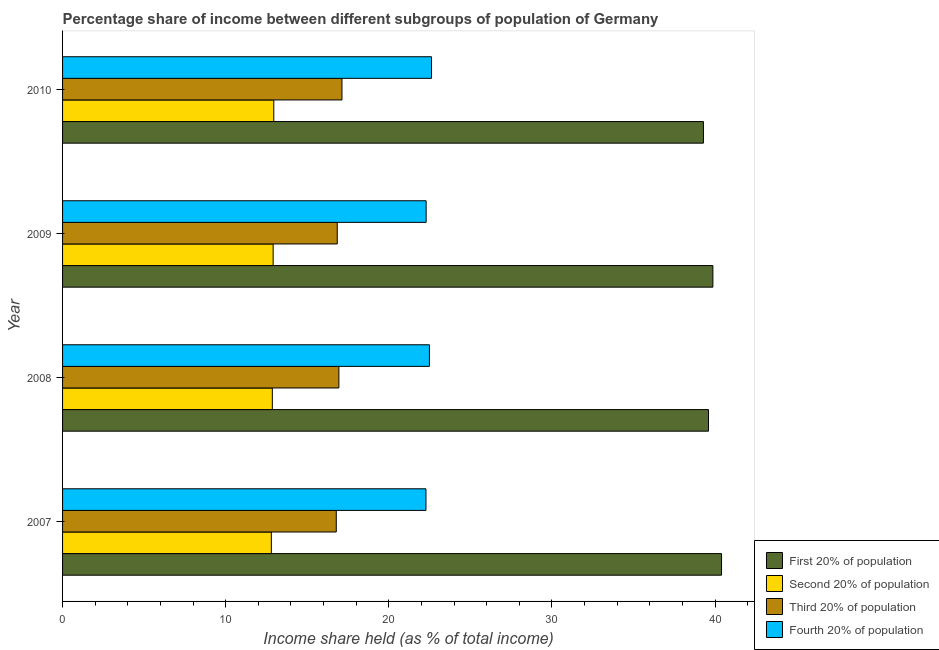Are the number of bars per tick equal to the number of legend labels?
Provide a short and direct response. Yes. How many bars are there on the 4th tick from the top?
Provide a succinct answer. 4. How many bars are there on the 1st tick from the bottom?
Provide a short and direct response. 4. What is the label of the 1st group of bars from the top?
Offer a terse response. 2010. In how many cases, is the number of bars for a given year not equal to the number of legend labels?
Provide a short and direct response. 0. What is the share of the income held by third 20% of the population in 2010?
Give a very brief answer. 17.13. Across all years, what is the maximum share of the income held by second 20% of the population?
Offer a terse response. 12.95. Across all years, what is the minimum share of the income held by third 20% of the population?
Keep it short and to the point. 16.78. In which year was the share of the income held by second 20% of the population maximum?
Offer a terse response. 2010. What is the total share of the income held by second 20% of the population in the graph?
Provide a short and direct response. 51.52. What is the difference between the share of the income held by fourth 20% of the population in 2010 and the share of the income held by first 20% of the population in 2009?
Make the answer very short. -17.25. What is the average share of the income held by first 20% of the population per year?
Provide a succinct answer. 39.79. In the year 2010, what is the difference between the share of the income held by second 20% of the population and share of the income held by first 20% of the population?
Your response must be concise. -26.34. In how many years, is the share of the income held by first 20% of the population greater than 26 %?
Make the answer very short. 4. Is the share of the income held by third 20% of the population in 2007 less than that in 2008?
Offer a very short reply. Yes. Is the difference between the share of the income held by first 20% of the population in 2007 and 2010 greater than the difference between the share of the income held by fourth 20% of the population in 2007 and 2010?
Ensure brevity in your answer.  Yes. What is the difference between the highest and the second highest share of the income held by third 20% of the population?
Your answer should be very brief. 0.19. What is the difference between the highest and the lowest share of the income held by third 20% of the population?
Your response must be concise. 0.35. In how many years, is the share of the income held by second 20% of the population greater than the average share of the income held by second 20% of the population taken over all years?
Make the answer very short. 2. Is the sum of the share of the income held by fourth 20% of the population in 2008 and 2009 greater than the maximum share of the income held by third 20% of the population across all years?
Give a very brief answer. Yes. Is it the case that in every year, the sum of the share of the income held by second 20% of the population and share of the income held by fourth 20% of the population is greater than the sum of share of the income held by third 20% of the population and share of the income held by first 20% of the population?
Keep it short and to the point. No. What does the 4th bar from the top in 2010 represents?
Provide a short and direct response. First 20% of population. What does the 3rd bar from the bottom in 2009 represents?
Provide a succinct answer. Third 20% of population. How many years are there in the graph?
Provide a succinct answer. 4. What is the difference between two consecutive major ticks on the X-axis?
Your answer should be compact. 10. Does the graph contain grids?
Provide a succinct answer. No. Where does the legend appear in the graph?
Provide a succinct answer. Bottom right. How are the legend labels stacked?
Provide a short and direct response. Vertical. What is the title of the graph?
Your response must be concise. Percentage share of income between different subgroups of population of Germany. Does "Management rating" appear as one of the legend labels in the graph?
Make the answer very short. No. What is the label or title of the X-axis?
Ensure brevity in your answer.  Income share held (as % of total income). What is the label or title of the Y-axis?
Offer a terse response. Year. What is the Income share held (as % of total income) of First 20% of population in 2007?
Offer a very short reply. 40.4. What is the Income share held (as % of total income) in Third 20% of population in 2007?
Keep it short and to the point. 16.78. What is the Income share held (as % of total income) of Fourth 20% of population in 2007?
Ensure brevity in your answer.  22.28. What is the Income share held (as % of total income) in First 20% of population in 2008?
Offer a very short reply. 39.6. What is the Income share held (as % of total income) of Second 20% of population in 2008?
Your answer should be very brief. 12.86. What is the Income share held (as % of total income) of Third 20% of population in 2008?
Your response must be concise. 16.94. What is the Income share held (as % of total income) in Fourth 20% of population in 2008?
Your answer should be compact. 22.49. What is the Income share held (as % of total income) of First 20% of population in 2009?
Keep it short and to the point. 39.87. What is the Income share held (as % of total income) of Second 20% of population in 2009?
Provide a succinct answer. 12.91. What is the Income share held (as % of total income) in Third 20% of population in 2009?
Your answer should be compact. 16.84. What is the Income share held (as % of total income) in Fourth 20% of population in 2009?
Your answer should be very brief. 22.29. What is the Income share held (as % of total income) in First 20% of population in 2010?
Offer a terse response. 39.29. What is the Income share held (as % of total income) of Second 20% of population in 2010?
Give a very brief answer. 12.95. What is the Income share held (as % of total income) in Third 20% of population in 2010?
Keep it short and to the point. 17.13. What is the Income share held (as % of total income) of Fourth 20% of population in 2010?
Give a very brief answer. 22.62. Across all years, what is the maximum Income share held (as % of total income) of First 20% of population?
Offer a very short reply. 40.4. Across all years, what is the maximum Income share held (as % of total income) of Second 20% of population?
Your answer should be compact. 12.95. Across all years, what is the maximum Income share held (as % of total income) in Third 20% of population?
Keep it short and to the point. 17.13. Across all years, what is the maximum Income share held (as % of total income) in Fourth 20% of population?
Your response must be concise. 22.62. Across all years, what is the minimum Income share held (as % of total income) in First 20% of population?
Offer a very short reply. 39.29. Across all years, what is the minimum Income share held (as % of total income) in Third 20% of population?
Your response must be concise. 16.78. Across all years, what is the minimum Income share held (as % of total income) in Fourth 20% of population?
Make the answer very short. 22.28. What is the total Income share held (as % of total income) of First 20% of population in the graph?
Keep it short and to the point. 159.16. What is the total Income share held (as % of total income) of Second 20% of population in the graph?
Your answer should be compact. 51.52. What is the total Income share held (as % of total income) of Third 20% of population in the graph?
Give a very brief answer. 67.69. What is the total Income share held (as % of total income) of Fourth 20% of population in the graph?
Offer a very short reply. 89.68. What is the difference between the Income share held (as % of total income) of First 20% of population in 2007 and that in 2008?
Provide a short and direct response. 0.8. What is the difference between the Income share held (as % of total income) of Second 20% of population in 2007 and that in 2008?
Ensure brevity in your answer.  -0.06. What is the difference between the Income share held (as % of total income) in Third 20% of population in 2007 and that in 2008?
Your response must be concise. -0.16. What is the difference between the Income share held (as % of total income) in Fourth 20% of population in 2007 and that in 2008?
Give a very brief answer. -0.21. What is the difference between the Income share held (as % of total income) in First 20% of population in 2007 and that in 2009?
Ensure brevity in your answer.  0.53. What is the difference between the Income share held (as % of total income) of Second 20% of population in 2007 and that in 2009?
Your answer should be compact. -0.11. What is the difference between the Income share held (as % of total income) in Third 20% of population in 2007 and that in 2009?
Offer a very short reply. -0.06. What is the difference between the Income share held (as % of total income) of Fourth 20% of population in 2007 and that in 2009?
Offer a terse response. -0.01. What is the difference between the Income share held (as % of total income) in First 20% of population in 2007 and that in 2010?
Offer a very short reply. 1.11. What is the difference between the Income share held (as % of total income) in Second 20% of population in 2007 and that in 2010?
Make the answer very short. -0.15. What is the difference between the Income share held (as % of total income) in Third 20% of population in 2007 and that in 2010?
Ensure brevity in your answer.  -0.35. What is the difference between the Income share held (as % of total income) of Fourth 20% of population in 2007 and that in 2010?
Make the answer very short. -0.34. What is the difference between the Income share held (as % of total income) in First 20% of population in 2008 and that in 2009?
Give a very brief answer. -0.27. What is the difference between the Income share held (as % of total income) of First 20% of population in 2008 and that in 2010?
Your answer should be compact. 0.31. What is the difference between the Income share held (as % of total income) in Second 20% of population in 2008 and that in 2010?
Your response must be concise. -0.09. What is the difference between the Income share held (as % of total income) of Third 20% of population in 2008 and that in 2010?
Keep it short and to the point. -0.19. What is the difference between the Income share held (as % of total income) of Fourth 20% of population in 2008 and that in 2010?
Your answer should be compact. -0.13. What is the difference between the Income share held (as % of total income) in First 20% of population in 2009 and that in 2010?
Offer a very short reply. 0.58. What is the difference between the Income share held (as % of total income) in Second 20% of population in 2009 and that in 2010?
Provide a short and direct response. -0.04. What is the difference between the Income share held (as % of total income) in Third 20% of population in 2009 and that in 2010?
Your response must be concise. -0.29. What is the difference between the Income share held (as % of total income) in Fourth 20% of population in 2009 and that in 2010?
Provide a short and direct response. -0.33. What is the difference between the Income share held (as % of total income) of First 20% of population in 2007 and the Income share held (as % of total income) of Second 20% of population in 2008?
Provide a short and direct response. 27.54. What is the difference between the Income share held (as % of total income) of First 20% of population in 2007 and the Income share held (as % of total income) of Third 20% of population in 2008?
Keep it short and to the point. 23.46. What is the difference between the Income share held (as % of total income) in First 20% of population in 2007 and the Income share held (as % of total income) in Fourth 20% of population in 2008?
Offer a terse response. 17.91. What is the difference between the Income share held (as % of total income) of Second 20% of population in 2007 and the Income share held (as % of total income) of Third 20% of population in 2008?
Your answer should be very brief. -4.14. What is the difference between the Income share held (as % of total income) of Second 20% of population in 2007 and the Income share held (as % of total income) of Fourth 20% of population in 2008?
Make the answer very short. -9.69. What is the difference between the Income share held (as % of total income) of Third 20% of population in 2007 and the Income share held (as % of total income) of Fourth 20% of population in 2008?
Give a very brief answer. -5.71. What is the difference between the Income share held (as % of total income) of First 20% of population in 2007 and the Income share held (as % of total income) of Second 20% of population in 2009?
Offer a very short reply. 27.49. What is the difference between the Income share held (as % of total income) of First 20% of population in 2007 and the Income share held (as % of total income) of Third 20% of population in 2009?
Provide a succinct answer. 23.56. What is the difference between the Income share held (as % of total income) of First 20% of population in 2007 and the Income share held (as % of total income) of Fourth 20% of population in 2009?
Offer a very short reply. 18.11. What is the difference between the Income share held (as % of total income) of Second 20% of population in 2007 and the Income share held (as % of total income) of Third 20% of population in 2009?
Make the answer very short. -4.04. What is the difference between the Income share held (as % of total income) of Second 20% of population in 2007 and the Income share held (as % of total income) of Fourth 20% of population in 2009?
Give a very brief answer. -9.49. What is the difference between the Income share held (as % of total income) in Third 20% of population in 2007 and the Income share held (as % of total income) in Fourth 20% of population in 2009?
Keep it short and to the point. -5.51. What is the difference between the Income share held (as % of total income) of First 20% of population in 2007 and the Income share held (as % of total income) of Second 20% of population in 2010?
Offer a very short reply. 27.45. What is the difference between the Income share held (as % of total income) in First 20% of population in 2007 and the Income share held (as % of total income) in Third 20% of population in 2010?
Your response must be concise. 23.27. What is the difference between the Income share held (as % of total income) in First 20% of population in 2007 and the Income share held (as % of total income) in Fourth 20% of population in 2010?
Offer a very short reply. 17.78. What is the difference between the Income share held (as % of total income) of Second 20% of population in 2007 and the Income share held (as % of total income) of Third 20% of population in 2010?
Give a very brief answer. -4.33. What is the difference between the Income share held (as % of total income) in Second 20% of population in 2007 and the Income share held (as % of total income) in Fourth 20% of population in 2010?
Ensure brevity in your answer.  -9.82. What is the difference between the Income share held (as % of total income) in Third 20% of population in 2007 and the Income share held (as % of total income) in Fourth 20% of population in 2010?
Make the answer very short. -5.84. What is the difference between the Income share held (as % of total income) in First 20% of population in 2008 and the Income share held (as % of total income) in Second 20% of population in 2009?
Offer a very short reply. 26.69. What is the difference between the Income share held (as % of total income) in First 20% of population in 2008 and the Income share held (as % of total income) in Third 20% of population in 2009?
Ensure brevity in your answer.  22.76. What is the difference between the Income share held (as % of total income) in First 20% of population in 2008 and the Income share held (as % of total income) in Fourth 20% of population in 2009?
Your answer should be compact. 17.31. What is the difference between the Income share held (as % of total income) in Second 20% of population in 2008 and the Income share held (as % of total income) in Third 20% of population in 2009?
Give a very brief answer. -3.98. What is the difference between the Income share held (as % of total income) in Second 20% of population in 2008 and the Income share held (as % of total income) in Fourth 20% of population in 2009?
Provide a succinct answer. -9.43. What is the difference between the Income share held (as % of total income) of Third 20% of population in 2008 and the Income share held (as % of total income) of Fourth 20% of population in 2009?
Give a very brief answer. -5.35. What is the difference between the Income share held (as % of total income) of First 20% of population in 2008 and the Income share held (as % of total income) of Second 20% of population in 2010?
Your answer should be very brief. 26.65. What is the difference between the Income share held (as % of total income) in First 20% of population in 2008 and the Income share held (as % of total income) in Third 20% of population in 2010?
Provide a succinct answer. 22.47. What is the difference between the Income share held (as % of total income) in First 20% of population in 2008 and the Income share held (as % of total income) in Fourth 20% of population in 2010?
Offer a terse response. 16.98. What is the difference between the Income share held (as % of total income) of Second 20% of population in 2008 and the Income share held (as % of total income) of Third 20% of population in 2010?
Your answer should be very brief. -4.27. What is the difference between the Income share held (as % of total income) of Second 20% of population in 2008 and the Income share held (as % of total income) of Fourth 20% of population in 2010?
Your response must be concise. -9.76. What is the difference between the Income share held (as % of total income) of Third 20% of population in 2008 and the Income share held (as % of total income) of Fourth 20% of population in 2010?
Give a very brief answer. -5.68. What is the difference between the Income share held (as % of total income) in First 20% of population in 2009 and the Income share held (as % of total income) in Second 20% of population in 2010?
Your answer should be very brief. 26.92. What is the difference between the Income share held (as % of total income) of First 20% of population in 2009 and the Income share held (as % of total income) of Third 20% of population in 2010?
Ensure brevity in your answer.  22.74. What is the difference between the Income share held (as % of total income) in First 20% of population in 2009 and the Income share held (as % of total income) in Fourth 20% of population in 2010?
Ensure brevity in your answer.  17.25. What is the difference between the Income share held (as % of total income) in Second 20% of population in 2009 and the Income share held (as % of total income) in Third 20% of population in 2010?
Your answer should be very brief. -4.22. What is the difference between the Income share held (as % of total income) in Second 20% of population in 2009 and the Income share held (as % of total income) in Fourth 20% of population in 2010?
Make the answer very short. -9.71. What is the difference between the Income share held (as % of total income) of Third 20% of population in 2009 and the Income share held (as % of total income) of Fourth 20% of population in 2010?
Give a very brief answer. -5.78. What is the average Income share held (as % of total income) in First 20% of population per year?
Ensure brevity in your answer.  39.79. What is the average Income share held (as % of total income) in Second 20% of population per year?
Keep it short and to the point. 12.88. What is the average Income share held (as % of total income) in Third 20% of population per year?
Your response must be concise. 16.92. What is the average Income share held (as % of total income) of Fourth 20% of population per year?
Make the answer very short. 22.42. In the year 2007, what is the difference between the Income share held (as % of total income) of First 20% of population and Income share held (as % of total income) of Second 20% of population?
Make the answer very short. 27.6. In the year 2007, what is the difference between the Income share held (as % of total income) in First 20% of population and Income share held (as % of total income) in Third 20% of population?
Give a very brief answer. 23.62. In the year 2007, what is the difference between the Income share held (as % of total income) of First 20% of population and Income share held (as % of total income) of Fourth 20% of population?
Keep it short and to the point. 18.12. In the year 2007, what is the difference between the Income share held (as % of total income) in Second 20% of population and Income share held (as % of total income) in Third 20% of population?
Give a very brief answer. -3.98. In the year 2007, what is the difference between the Income share held (as % of total income) in Second 20% of population and Income share held (as % of total income) in Fourth 20% of population?
Keep it short and to the point. -9.48. In the year 2008, what is the difference between the Income share held (as % of total income) in First 20% of population and Income share held (as % of total income) in Second 20% of population?
Your answer should be very brief. 26.74. In the year 2008, what is the difference between the Income share held (as % of total income) of First 20% of population and Income share held (as % of total income) of Third 20% of population?
Give a very brief answer. 22.66. In the year 2008, what is the difference between the Income share held (as % of total income) of First 20% of population and Income share held (as % of total income) of Fourth 20% of population?
Your answer should be compact. 17.11. In the year 2008, what is the difference between the Income share held (as % of total income) in Second 20% of population and Income share held (as % of total income) in Third 20% of population?
Keep it short and to the point. -4.08. In the year 2008, what is the difference between the Income share held (as % of total income) in Second 20% of population and Income share held (as % of total income) in Fourth 20% of population?
Your response must be concise. -9.63. In the year 2008, what is the difference between the Income share held (as % of total income) in Third 20% of population and Income share held (as % of total income) in Fourth 20% of population?
Your answer should be very brief. -5.55. In the year 2009, what is the difference between the Income share held (as % of total income) in First 20% of population and Income share held (as % of total income) in Second 20% of population?
Provide a succinct answer. 26.96. In the year 2009, what is the difference between the Income share held (as % of total income) in First 20% of population and Income share held (as % of total income) in Third 20% of population?
Make the answer very short. 23.03. In the year 2009, what is the difference between the Income share held (as % of total income) in First 20% of population and Income share held (as % of total income) in Fourth 20% of population?
Offer a terse response. 17.58. In the year 2009, what is the difference between the Income share held (as % of total income) of Second 20% of population and Income share held (as % of total income) of Third 20% of population?
Your response must be concise. -3.93. In the year 2009, what is the difference between the Income share held (as % of total income) in Second 20% of population and Income share held (as % of total income) in Fourth 20% of population?
Provide a short and direct response. -9.38. In the year 2009, what is the difference between the Income share held (as % of total income) in Third 20% of population and Income share held (as % of total income) in Fourth 20% of population?
Ensure brevity in your answer.  -5.45. In the year 2010, what is the difference between the Income share held (as % of total income) in First 20% of population and Income share held (as % of total income) in Second 20% of population?
Your answer should be compact. 26.34. In the year 2010, what is the difference between the Income share held (as % of total income) of First 20% of population and Income share held (as % of total income) of Third 20% of population?
Give a very brief answer. 22.16. In the year 2010, what is the difference between the Income share held (as % of total income) in First 20% of population and Income share held (as % of total income) in Fourth 20% of population?
Your answer should be compact. 16.67. In the year 2010, what is the difference between the Income share held (as % of total income) in Second 20% of population and Income share held (as % of total income) in Third 20% of population?
Offer a terse response. -4.18. In the year 2010, what is the difference between the Income share held (as % of total income) of Second 20% of population and Income share held (as % of total income) of Fourth 20% of population?
Your response must be concise. -9.67. In the year 2010, what is the difference between the Income share held (as % of total income) of Third 20% of population and Income share held (as % of total income) of Fourth 20% of population?
Keep it short and to the point. -5.49. What is the ratio of the Income share held (as % of total income) of First 20% of population in 2007 to that in 2008?
Give a very brief answer. 1.02. What is the ratio of the Income share held (as % of total income) of Third 20% of population in 2007 to that in 2008?
Give a very brief answer. 0.99. What is the ratio of the Income share held (as % of total income) in First 20% of population in 2007 to that in 2009?
Make the answer very short. 1.01. What is the ratio of the Income share held (as % of total income) in Third 20% of population in 2007 to that in 2009?
Make the answer very short. 1. What is the ratio of the Income share held (as % of total income) in First 20% of population in 2007 to that in 2010?
Ensure brevity in your answer.  1.03. What is the ratio of the Income share held (as % of total income) in Second 20% of population in 2007 to that in 2010?
Offer a terse response. 0.99. What is the ratio of the Income share held (as % of total income) in Third 20% of population in 2007 to that in 2010?
Provide a short and direct response. 0.98. What is the ratio of the Income share held (as % of total income) of Fourth 20% of population in 2007 to that in 2010?
Give a very brief answer. 0.98. What is the ratio of the Income share held (as % of total income) in First 20% of population in 2008 to that in 2009?
Offer a very short reply. 0.99. What is the ratio of the Income share held (as % of total income) in Second 20% of population in 2008 to that in 2009?
Your answer should be very brief. 1. What is the ratio of the Income share held (as % of total income) of Third 20% of population in 2008 to that in 2009?
Offer a very short reply. 1.01. What is the ratio of the Income share held (as % of total income) in First 20% of population in 2008 to that in 2010?
Your answer should be compact. 1.01. What is the ratio of the Income share held (as % of total income) in Third 20% of population in 2008 to that in 2010?
Ensure brevity in your answer.  0.99. What is the ratio of the Income share held (as % of total income) in First 20% of population in 2009 to that in 2010?
Ensure brevity in your answer.  1.01. What is the ratio of the Income share held (as % of total income) of Second 20% of population in 2009 to that in 2010?
Provide a short and direct response. 1. What is the ratio of the Income share held (as % of total income) of Third 20% of population in 2009 to that in 2010?
Offer a very short reply. 0.98. What is the ratio of the Income share held (as % of total income) of Fourth 20% of population in 2009 to that in 2010?
Ensure brevity in your answer.  0.99. What is the difference between the highest and the second highest Income share held (as % of total income) in First 20% of population?
Ensure brevity in your answer.  0.53. What is the difference between the highest and the second highest Income share held (as % of total income) in Third 20% of population?
Provide a short and direct response. 0.19. What is the difference between the highest and the second highest Income share held (as % of total income) of Fourth 20% of population?
Offer a terse response. 0.13. What is the difference between the highest and the lowest Income share held (as % of total income) in First 20% of population?
Ensure brevity in your answer.  1.11. What is the difference between the highest and the lowest Income share held (as % of total income) in Second 20% of population?
Make the answer very short. 0.15. What is the difference between the highest and the lowest Income share held (as % of total income) in Fourth 20% of population?
Offer a very short reply. 0.34. 